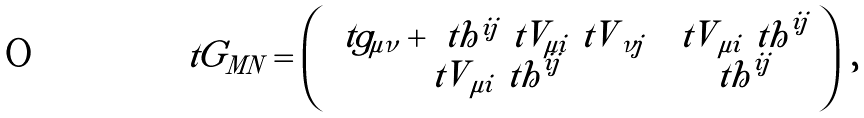<formula> <loc_0><loc_0><loc_500><loc_500>\ t { G } _ { M N } = \left ( \begin{array} { c c } \ t { g } _ { \mu \nu } + \ t { h } ^ { i j } \ t { V } _ { \mu i } { \ t V } _ { \nu j } \, & { \ t V } _ { \mu i } { \ t h } ^ { i j } \\ { \ t V } _ { \mu i } { \ t h } ^ { i j } & { \ t h } ^ { i j } \end{array} \right ) \, ,</formula> 